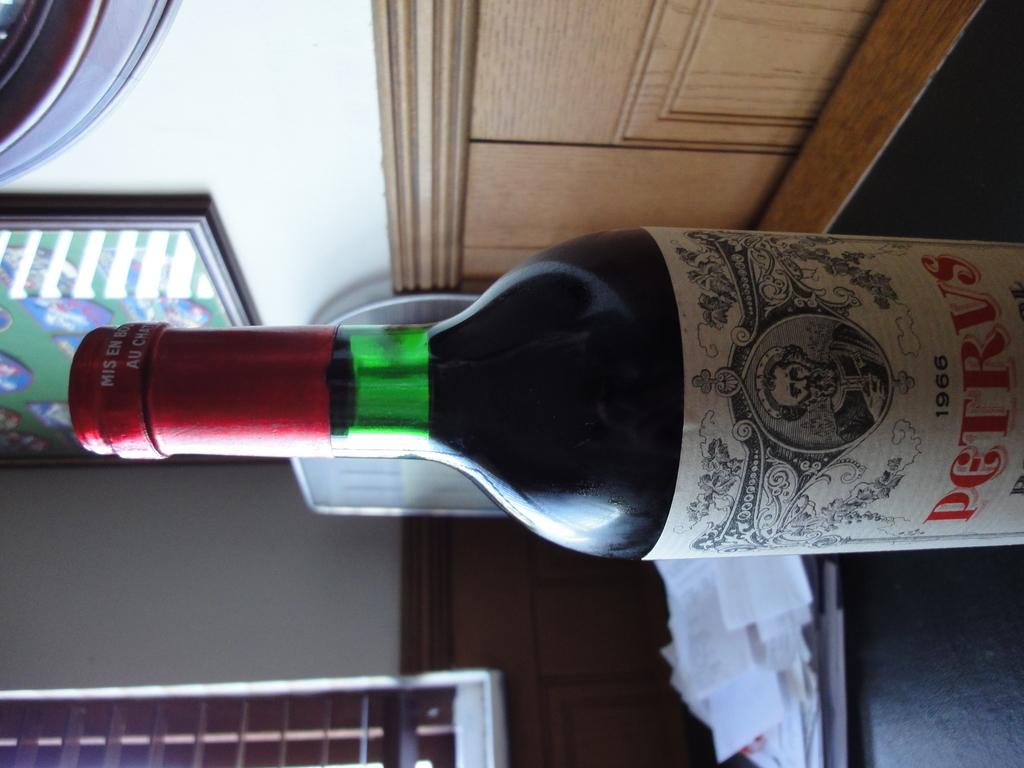What is the main object in the image? There is a wine bottle in the image. Where is the wine bottle located? The wine bottle is on the floor. What else can be seen in the image besides the wine bottle? There is a bunch of papers in the image. How are the papers positioned in the image? The papers are placed on the right side. What is the angle of the father's head in the image? There is no father present in the image, and therefore no angle of the head can be determined. 